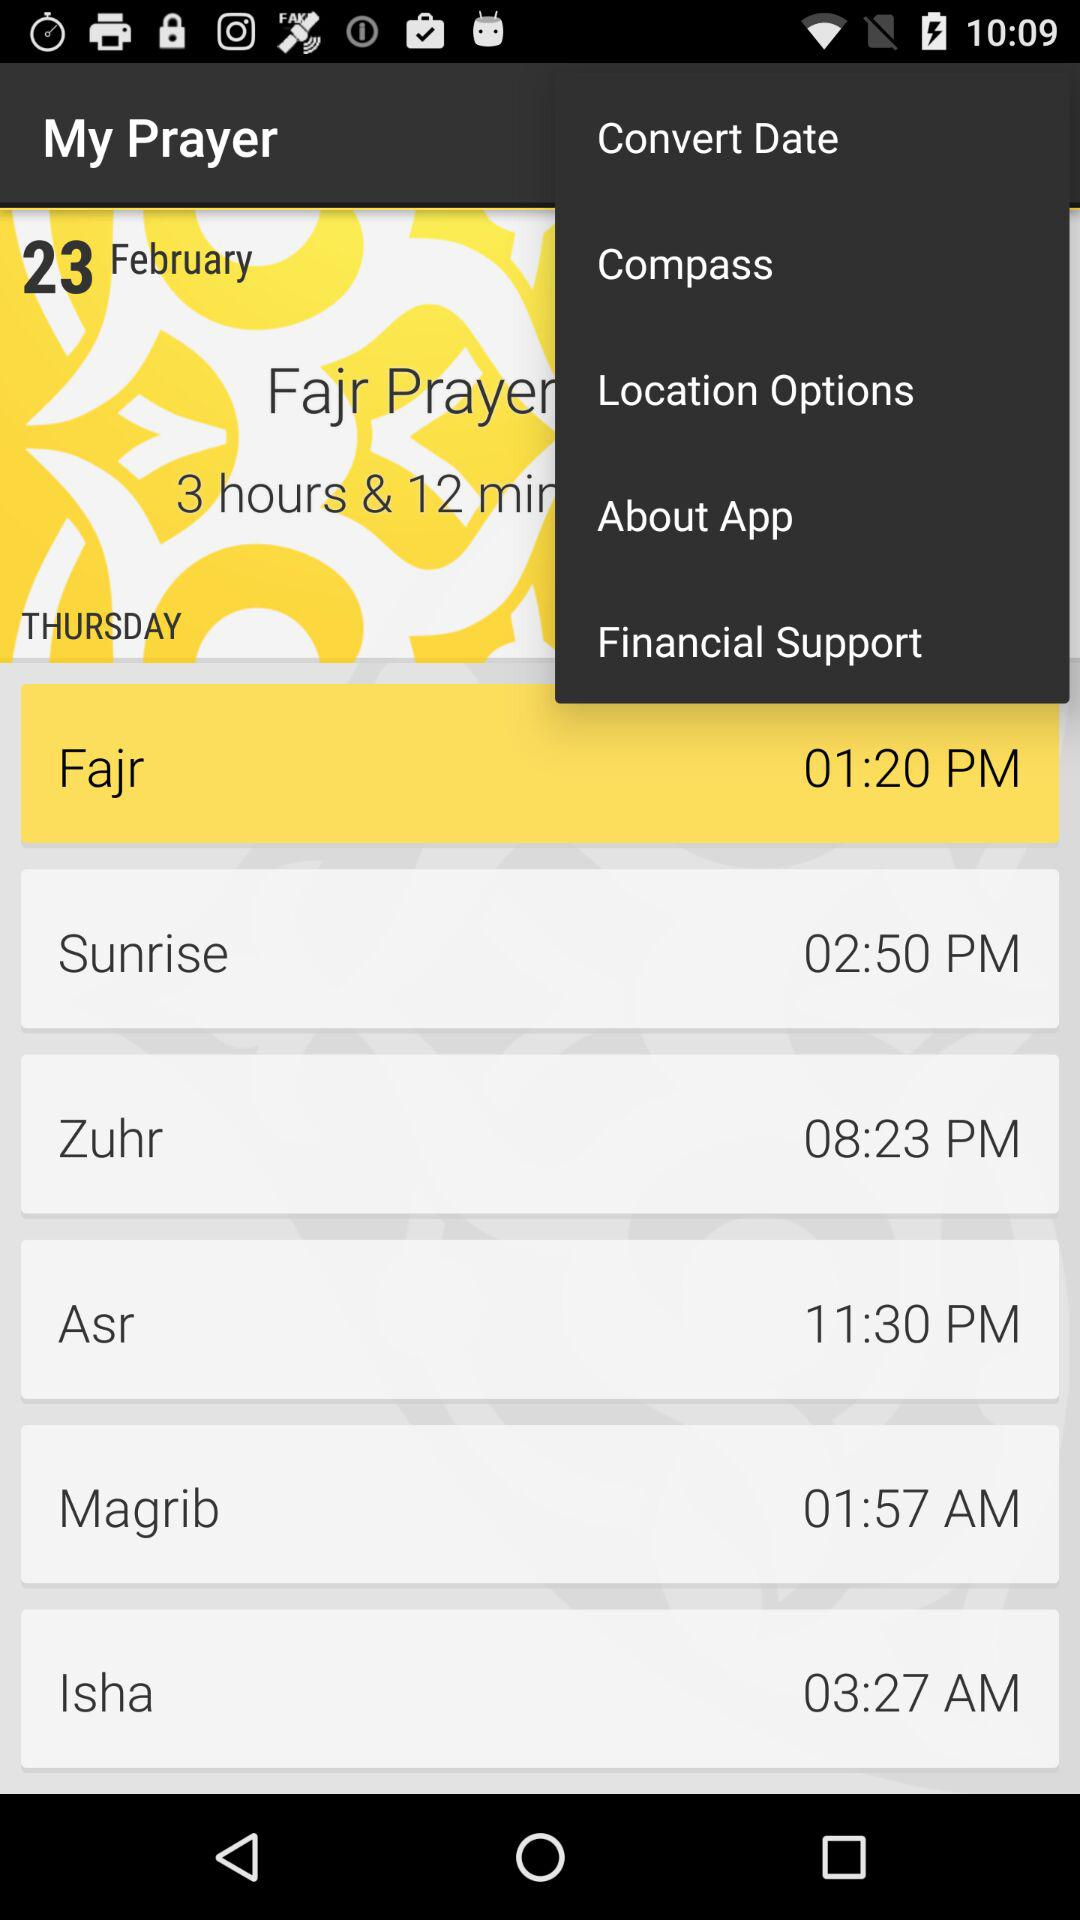What is the time of Fajr prayer? The time of Fajr prayer is 01:20 PM. 